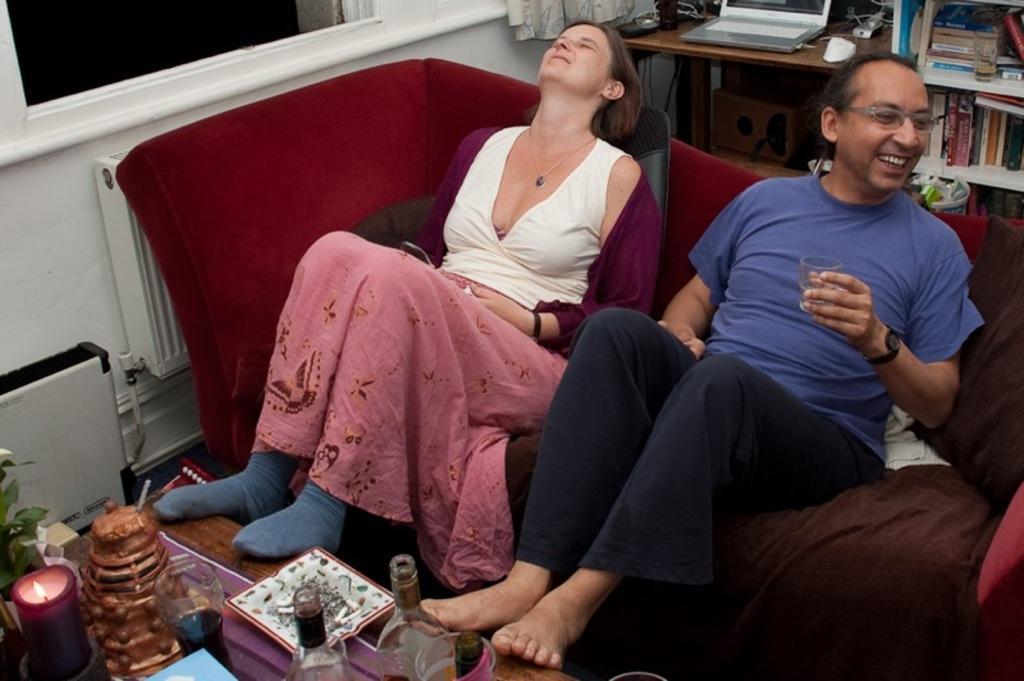Could you give a brief overview of what you see in this image? In the picture we can see table, bottles, plant, plate, candle, people, couch, cloth and various objects. At the top we can see table, bookshelf, books, laptop, cables, curtain, window and various objects. 